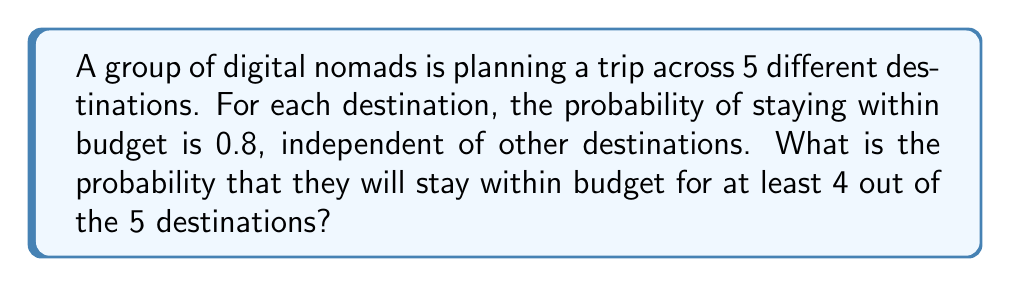Provide a solution to this math problem. Let's approach this step-by-step using the binomial probability distribution:

1) We can model this scenario as a binomial distribution with:
   $n = 5$ (number of destinations)
   $p = 0.8$ (probability of staying within budget for each destination)
   $X$ = number of destinations where they stay within budget

2) We want to find $P(X \geq 4)$, which is equivalent to $P(X = 4) + P(X = 5)$

3) The probability mass function for a binomial distribution is:
   $$P(X = k) = \binom{n}{k} p^k (1-p)^{n-k}$$

4) For $X = 4$:
   $$P(X = 4) = \binom{5}{4} (0.8)^4 (0.2)^1$$
   $$= 5 \cdot 0.4096 \cdot 0.2 = 0.4096$$

5) For $X = 5$:
   $$P(X = 5) = \binom{5}{5} (0.8)^5 (0.2)^0$$
   $$= 1 \cdot 0.32768 \cdot 1 = 0.32768$$

6) Therefore, $P(X \geq 4) = P(X = 4) + P(X = 5)$
   $$= 0.4096 + 0.32768 = 0.73728$$
Answer: 0.73728 